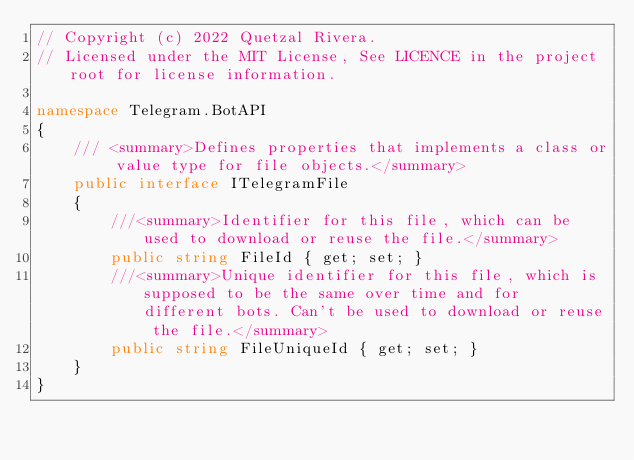<code> <loc_0><loc_0><loc_500><loc_500><_C#_>// Copyright (c) 2022 Quetzal Rivera.
// Licensed under the MIT License, See LICENCE in the project root for license information.

namespace Telegram.BotAPI
{
    /// <summary>Defines properties that implements a class or value type for file objects.</summary>
    public interface ITelegramFile
    {
        ///<summary>Identifier for this file, which can be used to download or reuse the file.</summary>
        public string FileId { get; set; }
        ///<summary>Unique identifier for this file, which is supposed to be the same over time and for different bots. Can't be used to download or reuse the file.</summary>
        public string FileUniqueId { get; set; }
    }
}
</code> 